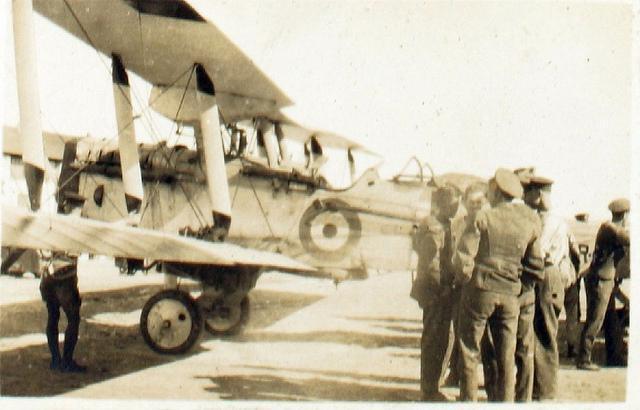How many people can you see?
Give a very brief answer. 6. 